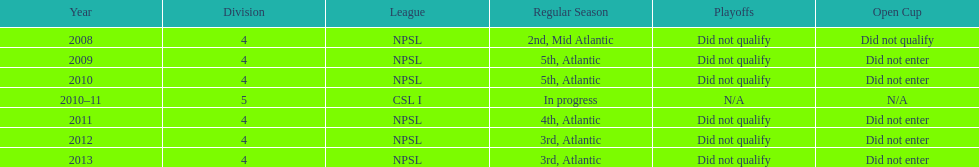Which year was more successful, 2010 or 2013? 2013. 